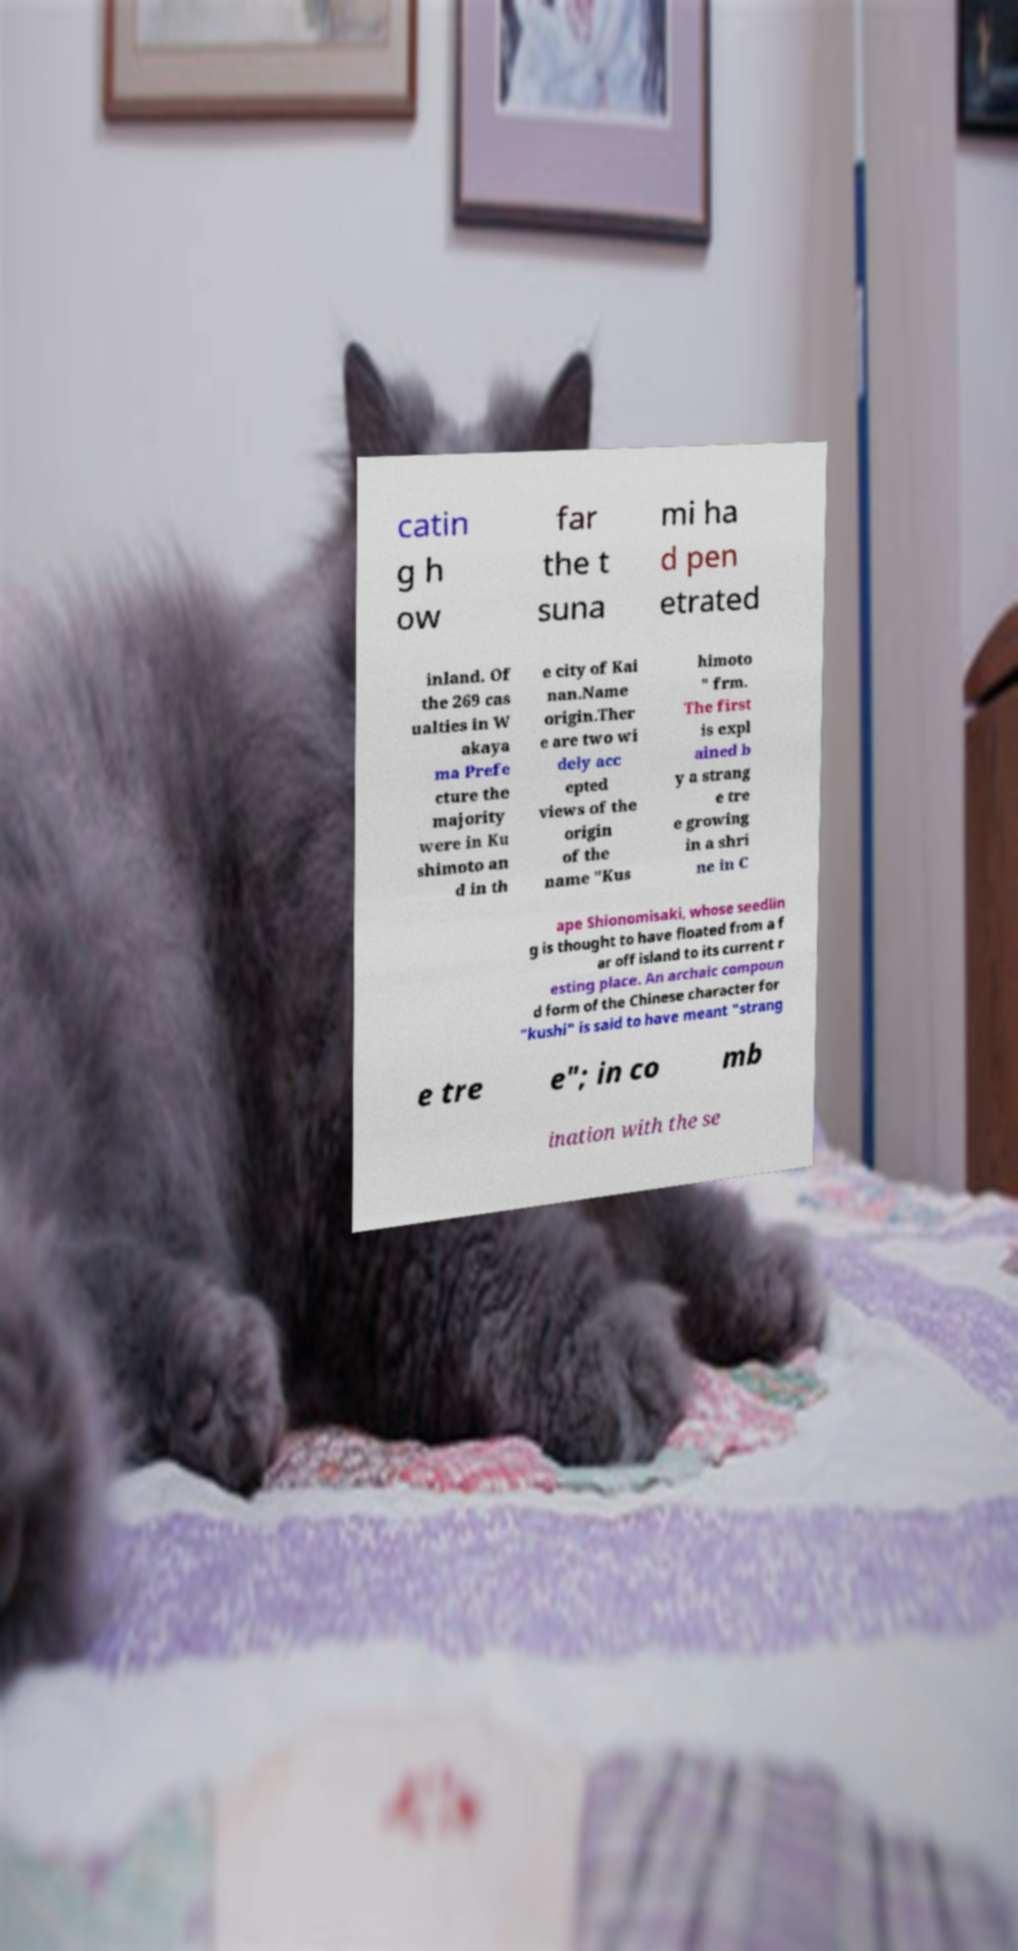What messages or text are displayed in this image? I need them in a readable, typed format. catin g h ow far the t suna mi ha d pen etrated inland. Of the 269 cas ualties in W akaya ma Prefe cture the majority were in Ku shimoto an d in th e city of Kai nan.Name origin.Ther e are two wi dely acc epted views of the origin of the name "Kus himoto " frm. The first is expl ained b y a strang e tre e growing in a shri ne in C ape Shionomisaki, whose seedlin g is thought to have floated from a f ar off island to its current r esting place. An archaic compoun d form of the Chinese character for "kushi" is said to have meant "strang e tre e"; in co mb ination with the se 